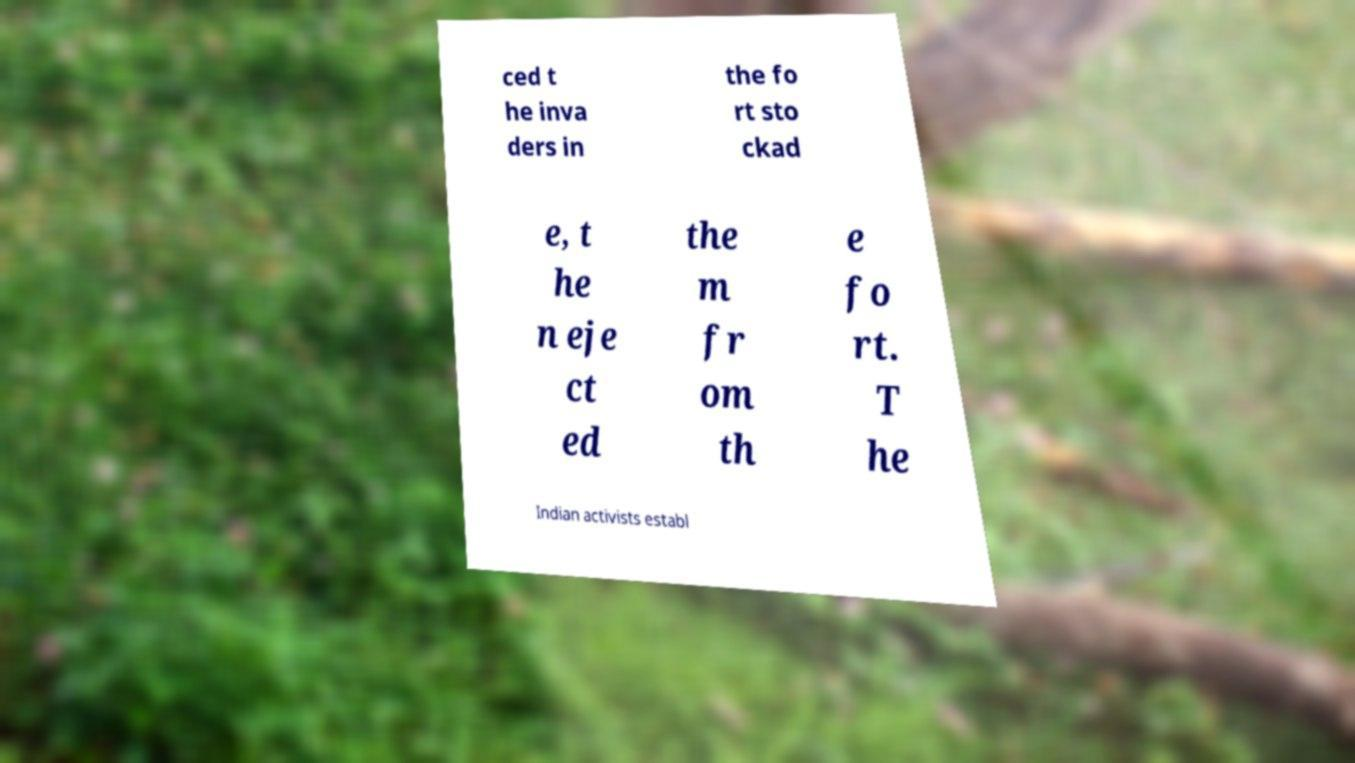Can you accurately transcribe the text from the provided image for me? ced t he inva ders in the fo rt sto ckad e, t he n eje ct ed the m fr om th e fo rt. T he Indian activists establ 